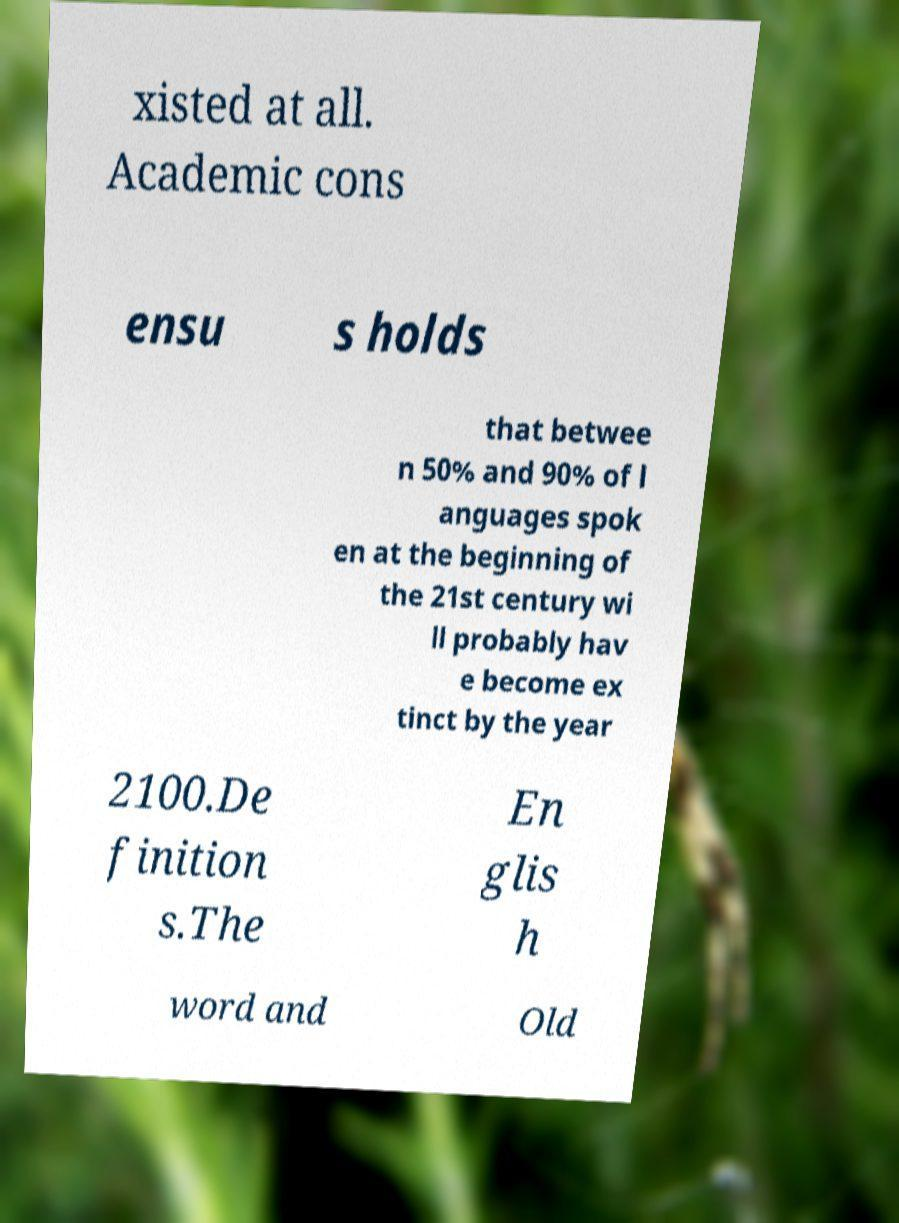Could you assist in decoding the text presented in this image and type it out clearly? xisted at all. Academic cons ensu s holds that betwee n 50% and 90% of l anguages spok en at the beginning of the 21st century wi ll probably hav e become ex tinct by the year 2100.De finition s.The En glis h word and Old 